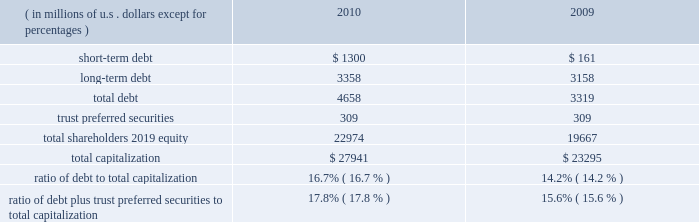Our consolidated net cash flows used for investing activities were $ 4.2 billion in 2010 , compared with $ 3.2 billion in 2009 .
Net investing activities for the indicated periods were related primarily to net purchases of fixed maturities and for 2010 included the acquisitions of rain and hail and jerneh insurance berhad .
Our consolidated net cash flows from financing activities were $ 732 million in 2010 , compared with net cash flows used for financing activities of $ 321 million in 2009 .
Net cash flows from/used for financing activities in 2010 and 2009 , included dividends paid on our common shares of $ 435 million and $ 388 million , respectively .
Net cash flows from financing activ- ities in 2010 , included net proceeds of $ 699 million from the issuance of long-term debt , $ 1 billion in reverse repurchase agreements , and $ 300 million in credit facility borrowings .
This was partially offset by repayment of $ 659 million in debt and share repurchases settled in 2010 of $ 235 million .
For 2009 , net cash flows used for financing activities included net pro- ceeds from the issuance of $ 500 million in long-term debt and the net repayment of debt and reverse repurchase agreements of $ 466 million .
Both internal and external forces influence our financial condition , results of operations , and cash flows .
Claim settle- ments , premium levels , and investment returns may be impacted by changing rates of inflation and other economic conditions .
In many cases , significant periods of time , ranging up to several years or more , may lapse between the occurrence of an insured loss , the reporting of the loss to us , and the settlement of the liability for that loss .
From time to time , we utilize reverse repurchase agreements as a low-cost alternative for short-term funding needs .
We use these instruments on a limited basis to address short-term cash timing differences without disrupting our investment portfolio holdings and settle the transactions with future operating cash flows .
At december 31 , 2010 , there were $ 1 billion in reverse repurchase agreements outstanding ( refer to short-term debt ) .
In addition to cash from operations , routine sales of investments , and financing arrangements , we have agreements with a bank provider which implemented two international multi-currency notional cash pooling programs to enhance cash management efficiency during periods of short-term timing mismatches between expected inflows and outflows of cash by currency .
In each program , participating ace entities establish deposit accounts in different currencies with the bank provider and each day the credit or debit balances in every account are notionally translated into a single currency ( u.s .
Dollars ) and then notionally pooled .
The bank extends overdraft credit to any participating ace entity as needed , provided that the overall notionally-pooled balance of all accounts in each pool at the end of each day is at least zero .
Actual cash balances are not physically converted and are not co-mingled between legal entities .
Ace entities may incur overdraft balances as a means to address short-term timing mismatches , and any overdraft balances incurred under this program by an ace entity would be guaranteed by ace limited ( up to $ 150 million in the aggregate ) .
Our revolving credit facility allows for same day drawings to fund a net pool overdraft should participating ace entities withdraw contributed funds from the pool .
Capital resources capital resources consist of funds deployed or available to be deployed to support our business operations .
The table summarizes the components of our capital resources at december 31 , 2010 , and 2009. .
Our ratios of debt to total capitalization and debt plus trust preferred securities to total capitalization have increased temporarily due to the increase in short-term debt , as discussed below .
We expect that these ratios will decline over the next six to nine months as we repay the short-term debt .
We believe our financial strength provides us with the flexibility and capacity to obtain available funds externally through debt or equity financing on both a short-term and long-term basis .
Our ability to access the capital markets is dependent on , among other things , market conditions and our perceived financial strength .
We have accessed both the debt and equity markets from time to time. .
In 2010 what was the ratio of the total debt to the shareholders equity? 
Computations: (4658 / 22974)
Answer: 0.20275. 